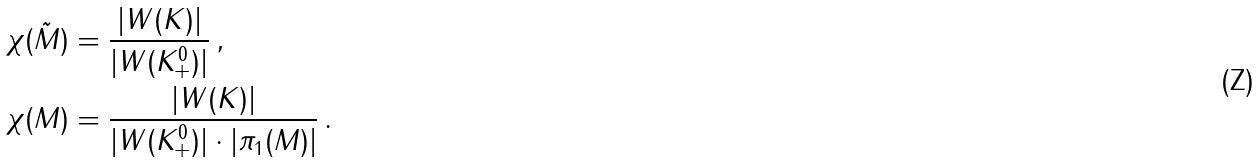Convert formula to latex. <formula><loc_0><loc_0><loc_500><loc_500>\chi ( \tilde { M } ) & = \frac { | W ( K ) | } { | W ( K _ { + } ^ { 0 } ) | } \, , \\ \chi ( M ) & = \frac { | W ( K ) | } { | W ( K _ { + } ^ { 0 } ) | \cdot | \pi _ { 1 } ( M ) | } \, .</formula> 